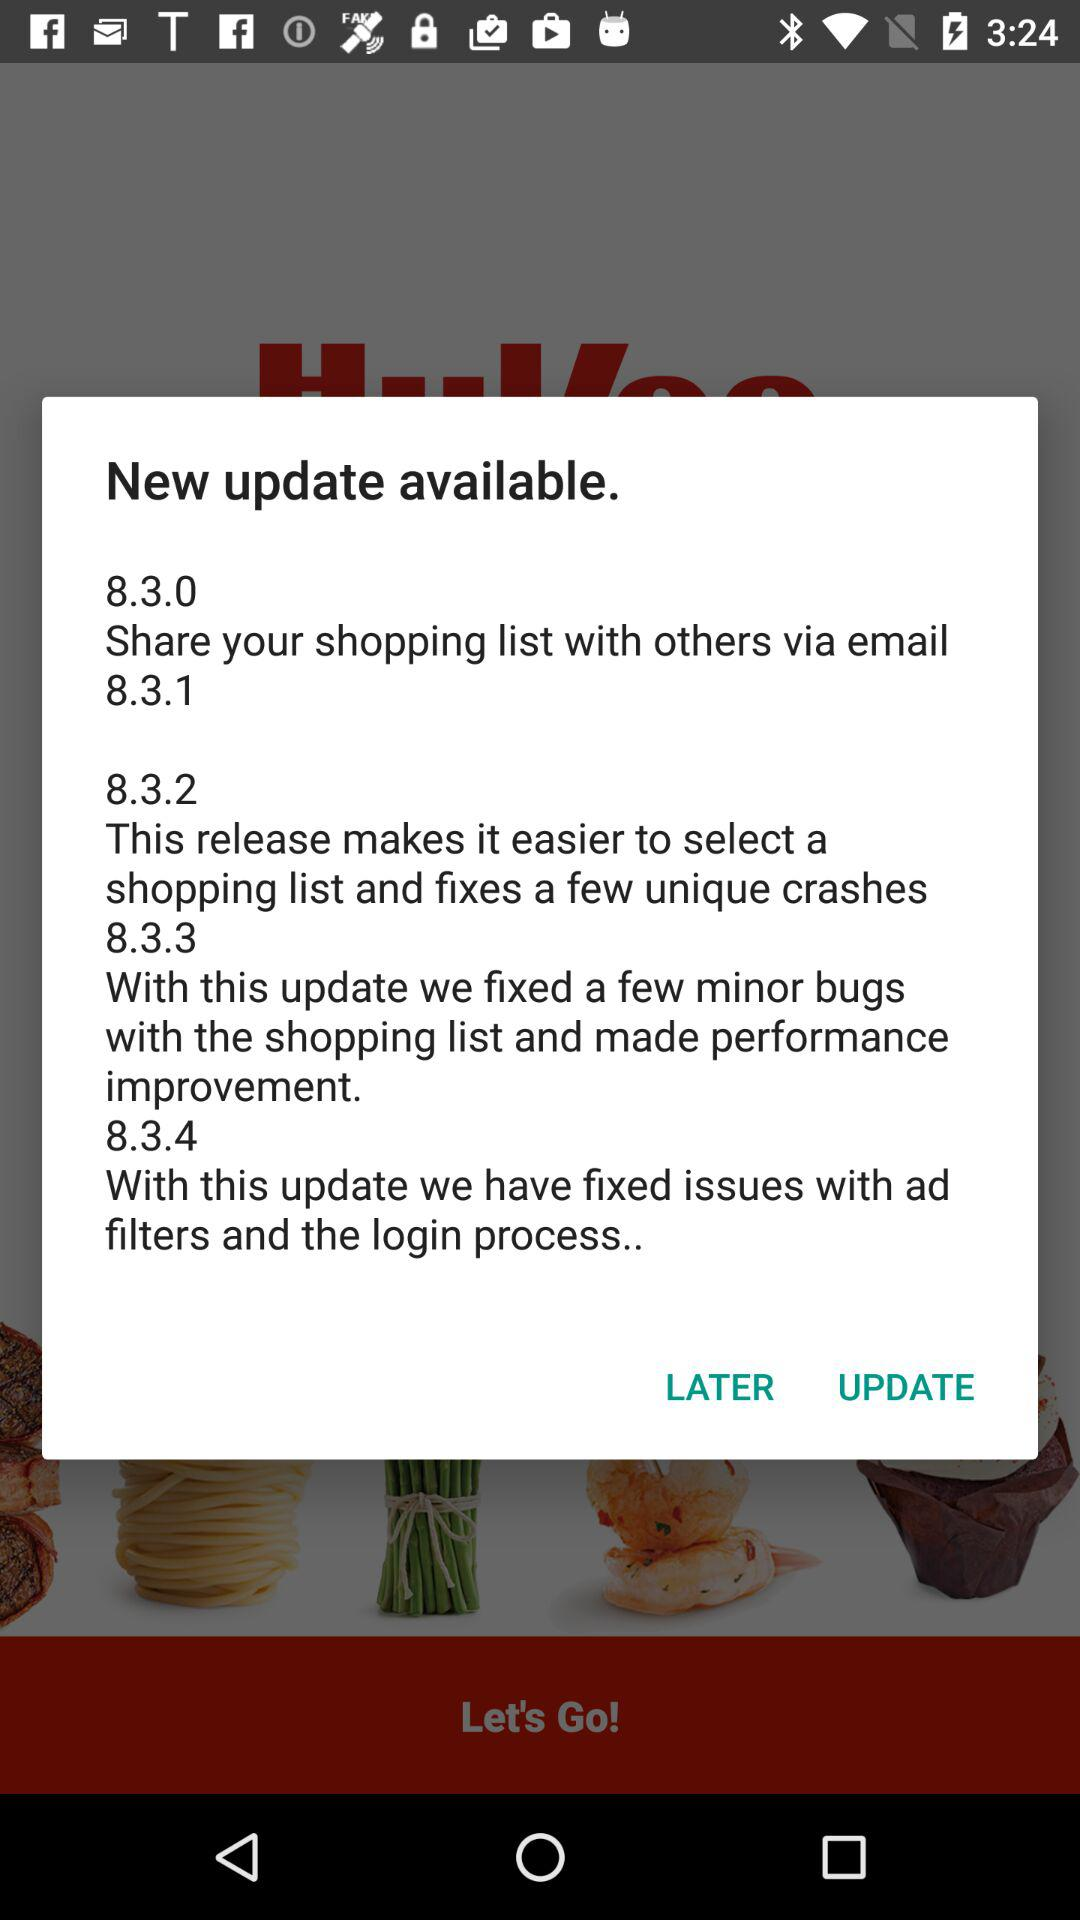What is the new update in 8.3.2? The new update in 8.3.2 is "This release makes it easier to select a shopping list and fixes a few unique crashes". 